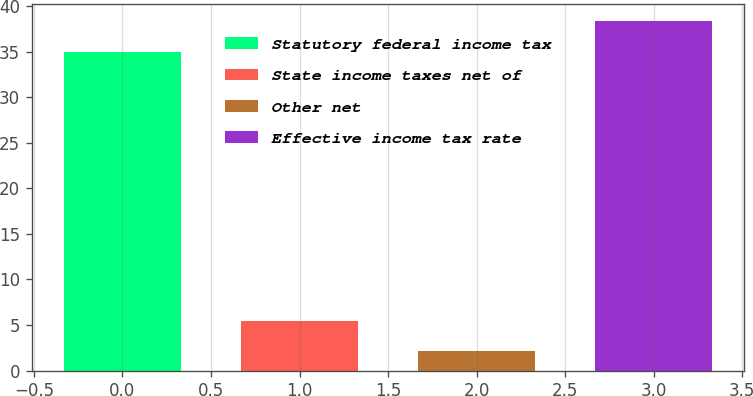Convert chart. <chart><loc_0><loc_0><loc_500><loc_500><bar_chart><fcel>Statutory federal income tax<fcel>State income taxes net of<fcel>Other net<fcel>Effective income tax rate<nl><fcel>35<fcel>5.4<fcel>2.1<fcel>38.3<nl></chart> 